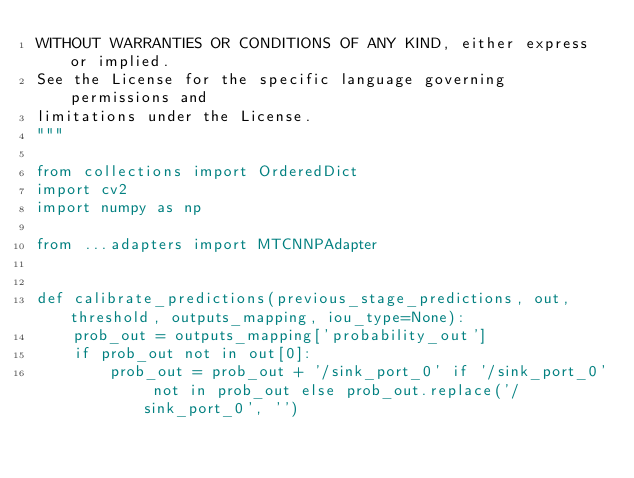Convert code to text. <code><loc_0><loc_0><loc_500><loc_500><_Python_>WITHOUT WARRANTIES OR CONDITIONS OF ANY KIND, either express or implied.
See the License for the specific language governing permissions and
limitations under the License.
"""

from collections import OrderedDict
import cv2
import numpy as np

from ...adapters import MTCNNPAdapter


def calibrate_predictions(previous_stage_predictions, out, threshold, outputs_mapping, iou_type=None):
    prob_out = outputs_mapping['probability_out']
    if prob_out not in out[0]:
        prob_out = prob_out + '/sink_port_0' if '/sink_port_0' not in prob_out else prob_out.replace('/sink_port_0', '')</code> 